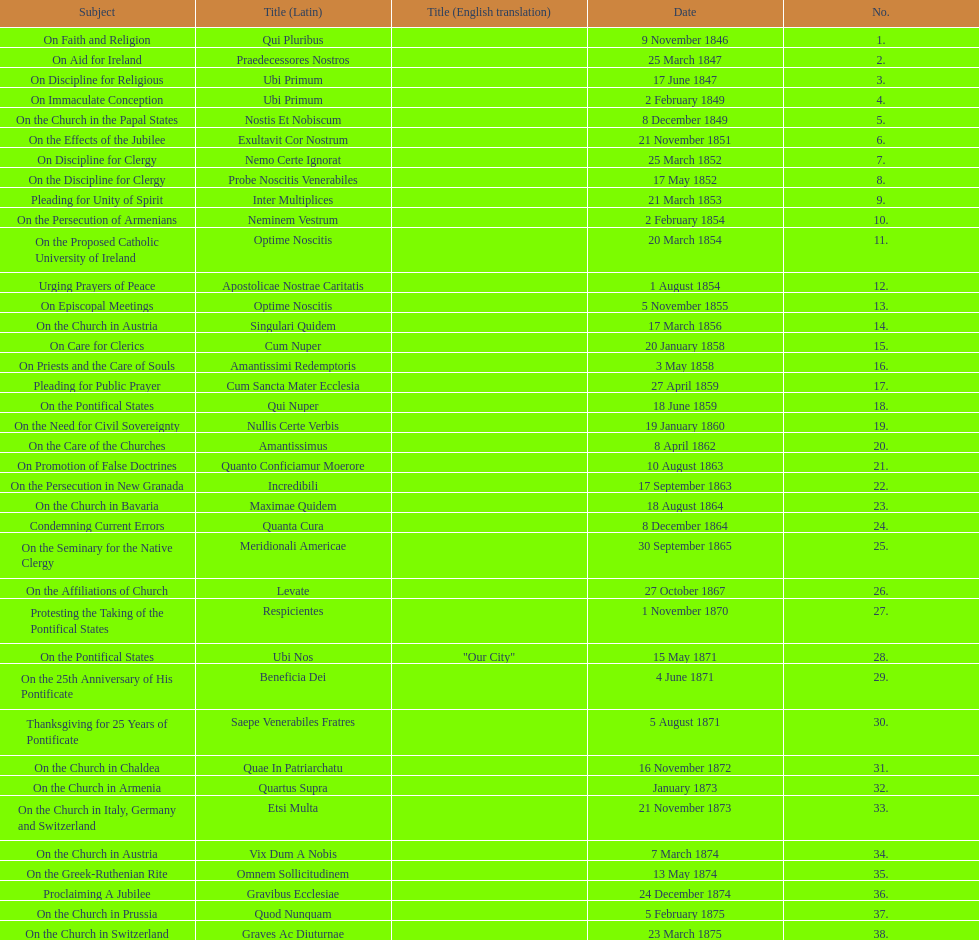Latin title of the encyclical before the encyclical with the subject "on the church in bavaria" Incredibili. 